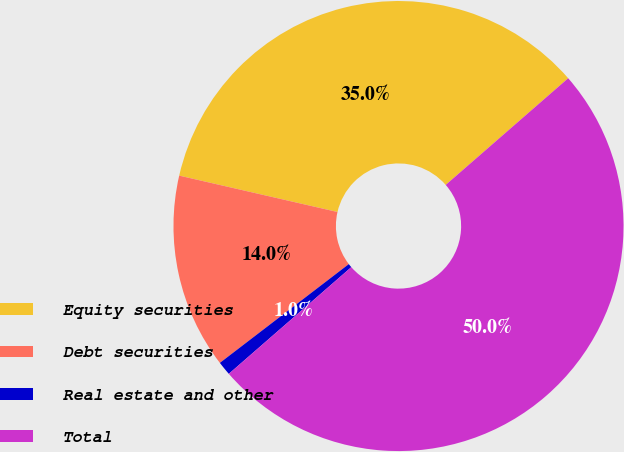<chart> <loc_0><loc_0><loc_500><loc_500><pie_chart><fcel>Equity securities<fcel>Debt securities<fcel>Real estate and other<fcel>Total<nl><fcel>35.0%<fcel>14.0%<fcel>1.0%<fcel>50.0%<nl></chart> 